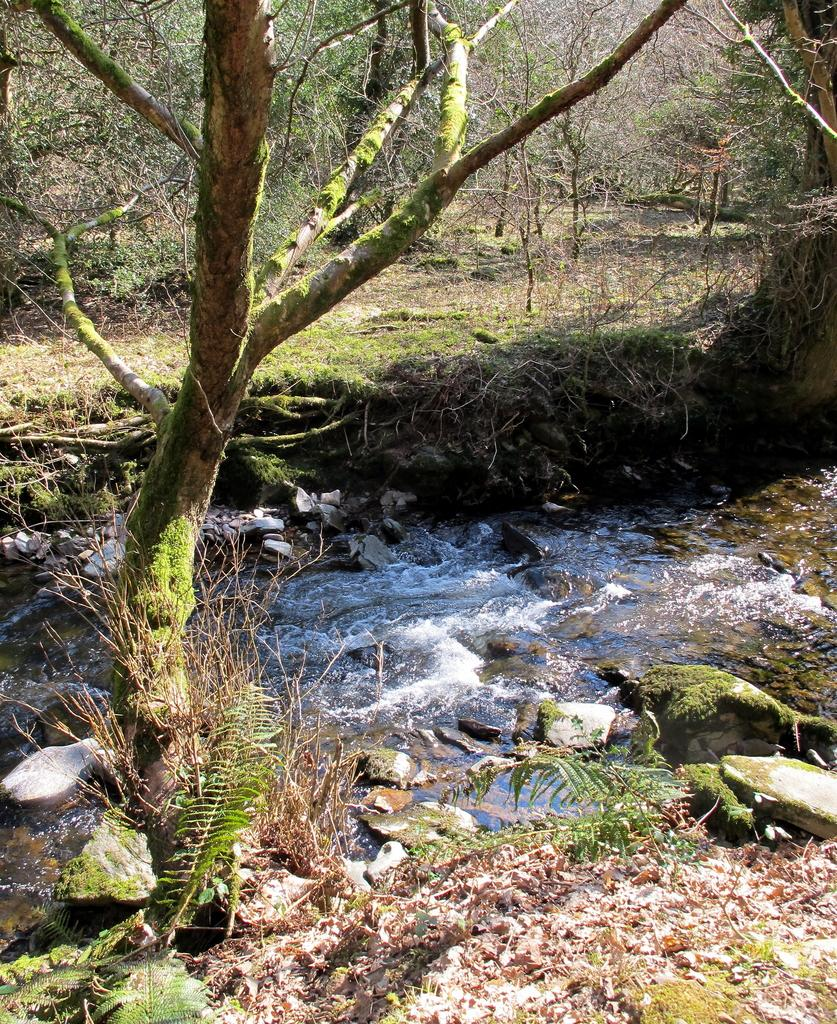What type of vegetation can be seen in the image? There are trees in the image. What is the color of the trees? The trees are green in color. What else is visible in the image besides the trees? There is water and rocks visible in the image. What type of card is being exchanged between the trees in the image? There is no card or exchange happening between the trees in the image; they are simply standing in their natural environment. 